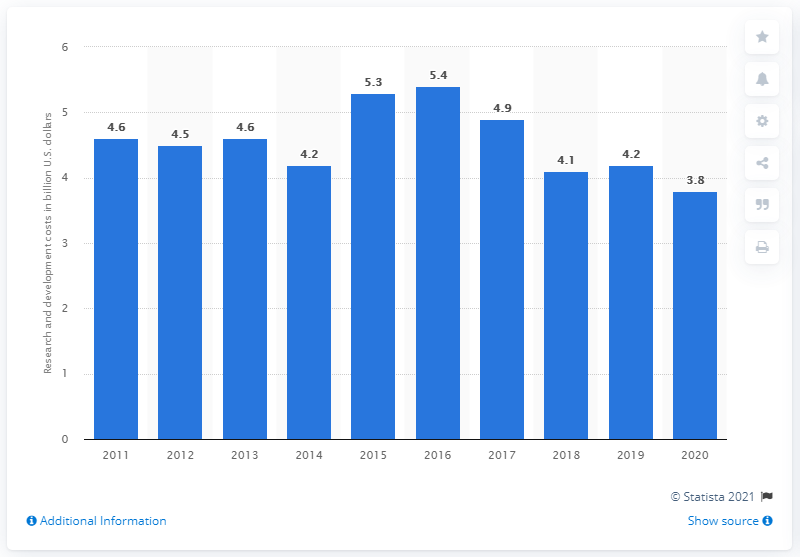Specify some key components in this picture. In 2011, General Electric first reported its research and development costs. General Electric spent approximately 3.8 billion dollars on research and development in the fiscal year of 2020. 